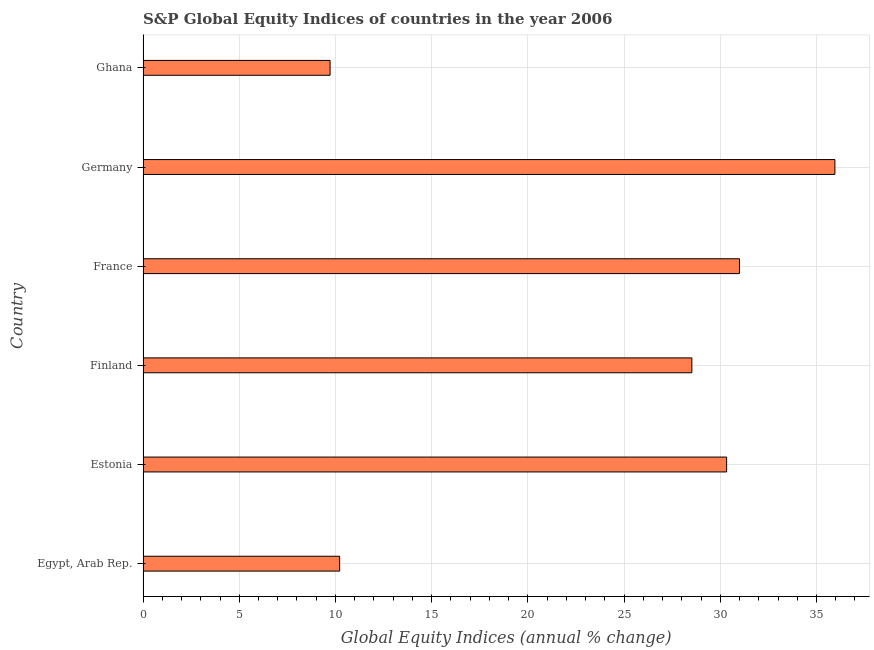Does the graph contain any zero values?
Offer a very short reply. No. What is the title of the graph?
Provide a succinct answer. S&P Global Equity Indices of countries in the year 2006. What is the label or title of the X-axis?
Offer a terse response. Global Equity Indices (annual % change). What is the s&p global equity indices in Egypt, Arab Rep.?
Offer a terse response. 10.22. Across all countries, what is the maximum s&p global equity indices?
Keep it short and to the point. 35.96. Across all countries, what is the minimum s&p global equity indices?
Your response must be concise. 9.72. In which country was the s&p global equity indices minimum?
Keep it short and to the point. Ghana. What is the sum of the s&p global equity indices?
Offer a very short reply. 145.74. What is the difference between the s&p global equity indices in Estonia and Ghana?
Give a very brief answer. 20.61. What is the average s&p global equity indices per country?
Provide a succinct answer. 24.29. What is the median s&p global equity indices?
Make the answer very short. 29.43. In how many countries, is the s&p global equity indices greater than 27 %?
Give a very brief answer. 4. What is the ratio of the s&p global equity indices in Egypt, Arab Rep. to that in Ghana?
Ensure brevity in your answer.  1.05. Is the difference between the s&p global equity indices in Estonia and Ghana greater than the difference between any two countries?
Provide a succinct answer. No. What is the difference between the highest and the second highest s&p global equity indices?
Provide a succinct answer. 4.96. What is the difference between the highest and the lowest s&p global equity indices?
Your response must be concise. 26.24. Are all the bars in the graph horizontal?
Offer a terse response. Yes. How many countries are there in the graph?
Your response must be concise. 6. What is the difference between two consecutive major ticks on the X-axis?
Your answer should be compact. 5. What is the Global Equity Indices (annual % change) of Egypt, Arab Rep.?
Ensure brevity in your answer.  10.22. What is the Global Equity Indices (annual % change) of Estonia?
Your answer should be compact. 30.33. What is the Global Equity Indices (annual % change) of Finland?
Offer a very short reply. 28.52. What is the Global Equity Indices (annual % change) of France?
Provide a short and direct response. 31. What is the Global Equity Indices (annual % change) in Germany?
Make the answer very short. 35.96. What is the Global Equity Indices (annual % change) of Ghana?
Your answer should be very brief. 9.72. What is the difference between the Global Equity Indices (annual % change) in Egypt, Arab Rep. and Estonia?
Offer a very short reply. -20.11. What is the difference between the Global Equity Indices (annual % change) in Egypt, Arab Rep. and Finland?
Your answer should be compact. -18.3. What is the difference between the Global Equity Indices (annual % change) in Egypt, Arab Rep. and France?
Provide a succinct answer. -20.78. What is the difference between the Global Equity Indices (annual % change) in Egypt, Arab Rep. and Germany?
Keep it short and to the point. -25.74. What is the difference between the Global Equity Indices (annual % change) in Egypt, Arab Rep. and Ghana?
Offer a very short reply. 0.5. What is the difference between the Global Equity Indices (annual % change) in Estonia and Finland?
Offer a terse response. 1.81. What is the difference between the Global Equity Indices (annual % change) in Estonia and France?
Make the answer very short. -0.67. What is the difference between the Global Equity Indices (annual % change) in Estonia and Germany?
Your answer should be compact. -5.63. What is the difference between the Global Equity Indices (annual % change) in Estonia and Ghana?
Ensure brevity in your answer.  20.61. What is the difference between the Global Equity Indices (annual % change) in Finland and France?
Keep it short and to the point. -2.48. What is the difference between the Global Equity Indices (annual % change) in Finland and Germany?
Offer a very short reply. -7.43. What is the difference between the Global Equity Indices (annual % change) in Finland and Ghana?
Your response must be concise. 18.8. What is the difference between the Global Equity Indices (annual % change) in France and Germany?
Offer a very short reply. -4.96. What is the difference between the Global Equity Indices (annual % change) in France and Ghana?
Ensure brevity in your answer.  21.28. What is the difference between the Global Equity Indices (annual % change) in Germany and Ghana?
Give a very brief answer. 26.24. What is the ratio of the Global Equity Indices (annual % change) in Egypt, Arab Rep. to that in Estonia?
Provide a short and direct response. 0.34. What is the ratio of the Global Equity Indices (annual % change) in Egypt, Arab Rep. to that in Finland?
Offer a very short reply. 0.36. What is the ratio of the Global Equity Indices (annual % change) in Egypt, Arab Rep. to that in France?
Provide a short and direct response. 0.33. What is the ratio of the Global Equity Indices (annual % change) in Egypt, Arab Rep. to that in Germany?
Your response must be concise. 0.28. What is the ratio of the Global Equity Indices (annual % change) in Egypt, Arab Rep. to that in Ghana?
Your answer should be compact. 1.05. What is the ratio of the Global Equity Indices (annual % change) in Estonia to that in Finland?
Provide a short and direct response. 1.06. What is the ratio of the Global Equity Indices (annual % change) in Estonia to that in Germany?
Your response must be concise. 0.84. What is the ratio of the Global Equity Indices (annual % change) in Estonia to that in Ghana?
Offer a very short reply. 3.12. What is the ratio of the Global Equity Indices (annual % change) in Finland to that in Germany?
Offer a very short reply. 0.79. What is the ratio of the Global Equity Indices (annual % change) in Finland to that in Ghana?
Provide a succinct answer. 2.93. What is the ratio of the Global Equity Indices (annual % change) in France to that in Germany?
Provide a succinct answer. 0.86. What is the ratio of the Global Equity Indices (annual % change) in France to that in Ghana?
Offer a very short reply. 3.19. What is the ratio of the Global Equity Indices (annual % change) in Germany to that in Ghana?
Your response must be concise. 3.7. 